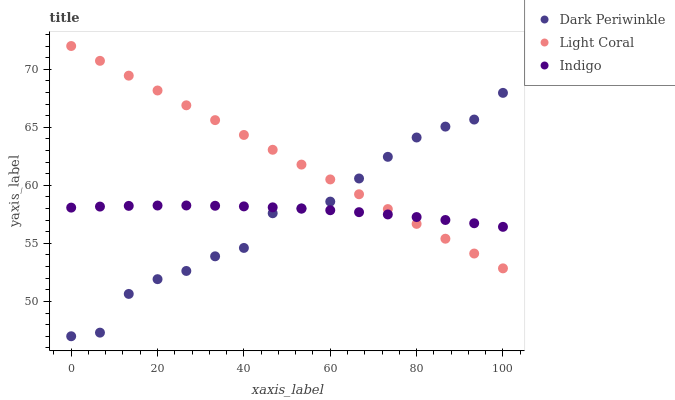Does Dark Periwinkle have the minimum area under the curve?
Answer yes or no. Yes. Does Light Coral have the maximum area under the curve?
Answer yes or no. Yes. Does Indigo have the minimum area under the curve?
Answer yes or no. No. Does Indigo have the maximum area under the curve?
Answer yes or no. No. Is Light Coral the smoothest?
Answer yes or no. Yes. Is Dark Periwinkle the roughest?
Answer yes or no. Yes. Is Indigo the smoothest?
Answer yes or no. No. Is Indigo the roughest?
Answer yes or no. No. Does Dark Periwinkle have the lowest value?
Answer yes or no. Yes. Does Indigo have the lowest value?
Answer yes or no. No. Does Light Coral have the highest value?
Answer yes or no. Yes. Does Dark Periwinkle have the highest value?
Answer yes or no. No. Does Dark Periwinkle intersect Light Coral?
Answer yes or no. Yes. Is Dark Periwinkle less than Light Coral?
Answer yes or no. No. Is Dark Periwinkle greater than Light Coral?
Answer yes or no. No. 